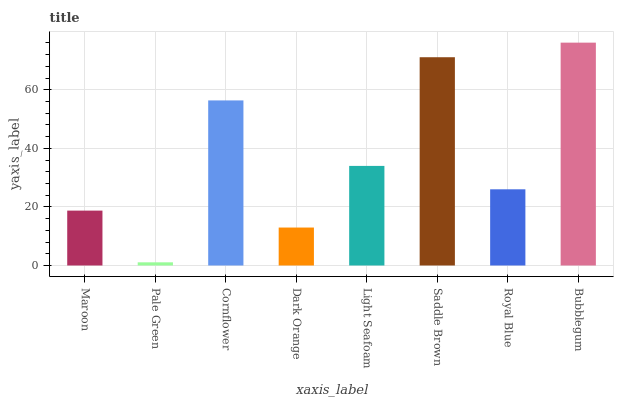Is Pale Green the minimum?
Answer yes or no. Yes. Is Bubblegum the maximum?
Answer yes or no. Yes. Is Cornflower the minimum?
Answer yes or no. No. Is Cornflower the maximum?
Answer yes or no. No. Is Cornflower greater than Pale Green?
Answer yes or no. Yes. Is Pale Green less than Cornflower?
Answer yes or no. Yes. Is Pale Green greater than Cornflower?
Answer yes or no. No. Is Cornflower less than Pale Green?
Answer yes or no. No. Is Light Seafoam the high median?
Answer yes or no. Yes. Is Royal Blue the low median?
Answer yes or no. Yes. Is Cornflower the high median?
Answer yes or no. No. Is Maroon the low median?
Answer yes or no. No. 